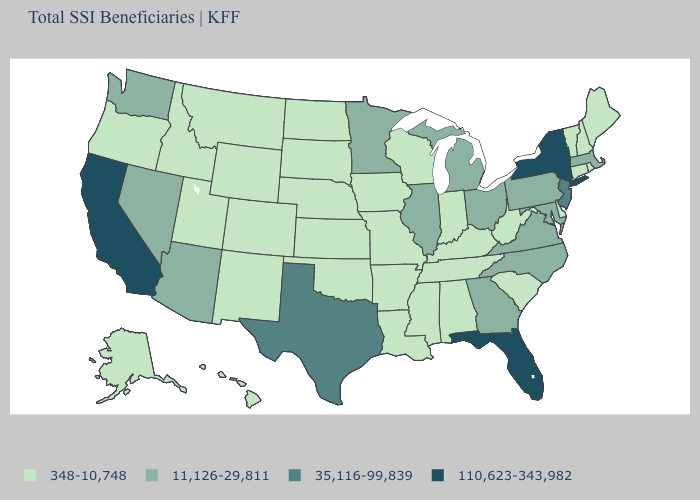What is the value of Florida?
Short answer required. 110,623-343,982. Among the states that border Delaware , which have the lowest value?
Give a very brief answer. Maryland, Pennsylvania. Is the legend a continuous bar?
Keep it brief. No. What is the value of Mississippi?
Quick response, please. 348-10,748. Is the legend a continuous bar?
Keep it brief. No. What is the value of North Carolina?
Give a very brief answer. 11,126-29,811. Among the states that border Vermont , which have the lowest value?
Be succinct. New Hampshire. Which states have the lowest value in the MidWest?
Write a very short answer. Indiana, Iowa, Kansas, Missouri, Nebraska, North Dakota, South Dakota, Wisconsin. Does the map have missing data?
Short answer required. No. Does Pennsylvania have the highest value in the Northeast?
Write a very short answer. No. Name the states that have a value in the range 11,126-29,811?
Give a very brief answer. Arizona, Georgia, Illinois, Maryland, Massachusetts, Michigan, Minnesota, Nevada, North Carolina, Ohio, Pennsylvania, Virginia, Washington. What is the highest value in the West ?
Write a very short answer. 110,623-343,982. Does North Dakota have the highest value in the MidWest?
Give a very brief answer. No. Name the states that have a value in the range 35,116-99,839?
Keep it brief. New Jersey, Texas. Which states have the lowest value in the USA?
Short answer required. Alabama, Alaska, Arkansas, Colorado, Connecticut, Delaware, Hawaii, Idaho, Indiana, Iowa, Kansas, Kentucky, Louisiana, Maine, Mississippi, Missouri, Montana, Nebraska, New Hampshire, New Mexico, North Dakota, Oklahoma, Oregon, Rhode Island, South Carolina, South Dakota, Tennessee, Utah, Vermont, West Virginia, Wisconsin, Wyoming. 